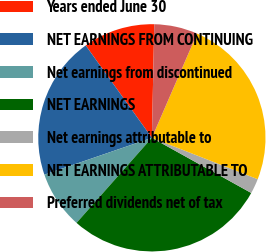Convert chart to OTSL. <chart><loc_0><loc_0><loc_500><loc_500><pie_chart><fcel>Years ended June 30<fcel>NET EARNINGS FROM CONTINUING<fcel>Net earnings from discontinued<fcel>NET EARNINGS<fcel>Net earnings attributable to<fcel>NET EARNINGS ATTRIBUTABLE TO<fcel>Preferred dividends net of tax<nl><fcel>10.23%<fcel>20.36%<fcel>8.21%<fcel>28.47%<fcel>2.13%<fcel>24.42%<fcel>6.18%<nl></chart> 